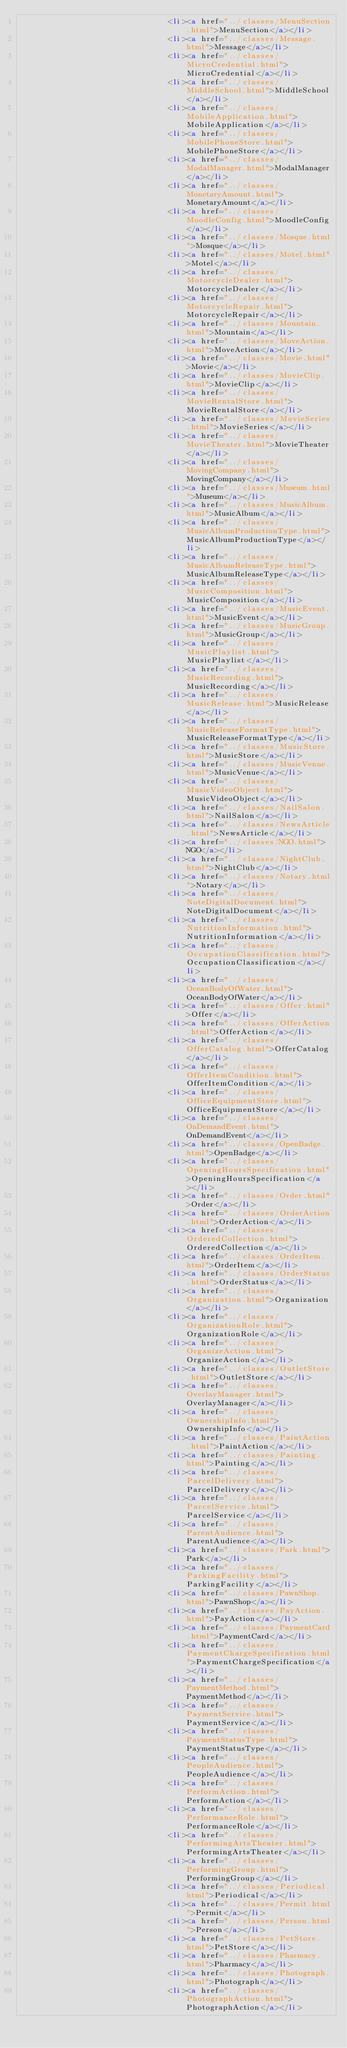<code> <loc_0><loc_0><loc_500><loc_500><_HTML_>                                <li><a href="../classes/MenuSection.html">MenuSection</a></li>
                                <li><a href="../classes/Message.html">Message</a></li>
                                <li><a href="../classes/MicroCredential.html">MicroCredential</a></li>
                                <li><a href="../classes/MiddleSchool.html">MiddleSchool</a></li>
                                <li><a href="../classes/MobileApplication.html">MobileApplication</a></li>
                                <li><a href="../classes/MobilePhoneStore.html">MobilePhoneStore</a></li>
                                <li><a href="../classes/ModalManager.html">ModalManager</a></li>
                                <li><a href="../classes/MonetaryAmount.html">MonetaryAmount</a></li>
                                <li><a href="../classes/MoodleConfig.html">MoodleConfig</a></li>
                                <li><a href="../classes/Mosque.html">Mosque</a></li>
                                <li><a href="../classes/Motel.html">Motel</a></li>
                                <li><a href="../classes/MotorcycleDealer.html">MotorcycleDealer</a></li>
                                <li><a href="../classes/MotorcycleRepair.html">MotorcycleRepair</a></li>
                                <li><a href="../classes/Mountain.html">Mountain</a></li>
                                <li><a href="../classes/MoveAction.html">MoveAction</a></li>
                                <li><a href="../classes/Movie.html">Movie</a></li>
                                <li><a href="../classes/MovieClip.html">MovieClip</a></li>
                                <li><a href="../classes/MovieRentalStore.html">MovieRentalStore</a></li>
                                <li><a href="../classes/MovieSeries.html">MovieSeries</a></li>
                                <li><a href="../classes/MovieTheater.html">MovieTheater</a></li>
                                <li><a href="../classes/MovingCompany.html">MovingCompany</a></li>
                                <li><a href="../classes/Museum.html">Museum</a></li>
                                <li><a href="../classes/MusicAlbum.html">MusicAlbum</a></li>
                                <li><a href="../classes/MusicAlbumProductionType.html">MusicAlbumProductionType</a></li>
                                <li><a href="../classes/MusicAlbumReleaseType.html">MusicAlbumReleaseType</a></li>
                                <li><a href="../classes/MusicComposition.html">MusicComposition</a></li>
                                <li><a href="../classes/MusicEvent.html">MusicEvent</a></li>
                                <li><a href="../classes/MusicGroup.html">MusicGroup</a></li>
                                <li><a href="../classes/MusicPlaylist.html">MusicPlaylist</a></li>
                                <li><a href="../classes/MusicRecording.html">MusicRecording</a></li>
                                <li><a href="../classes/MusicRelease.html">MusicRelease</a></li>
                                <li><a href="../classes/MusicReleaseFormatType.html">MusicReleaseFormatType</a></li>
                                <li><a href="../classes/MusicStore.html">MusicStore</a></li>
                                <li><a href="../classes/MusicVenue.html">MusicVenue</a></li>
                                <li><a href="../classes/MusicVideoObject.html">MusicVideoObject</a></li>
                                <li><a href="../classes/NailSalon.html">NailSalon</a></li>
                                <li><a href="../classes/NewsArticle.html">NewsArticle</a></li>
                                <li><a href="../classes/NGO.html">NGO</a></li>
                                <li><a href="../classes/NightClub.html">NightClub</a></li>
                                <li><a href="../classes/Notary.html">Notary</a></li>
                                <li><a href="../classes/NoteDigitalDocument.html">NoteDigitalDocument</a></li>
                                <li><a href="../classes/NutritionInformation.html">NutritionInformation</a></li>
                                <li><a href="../classes/OccupationClassification.html">OccupationClassification</a></li>
                                <li><a href="../classes/OceanBodyOfWater.html">OceanBodyOfWater</a></li>
                                <li><a href="../classes/Offer.html">Offer</a></li>
                                <li><a href="../classes/OfferAction.html">OfferAction</a></li>
                                <li><a href="../classes/OfferCatalog.html">OfferCatalog</a></li>
                                <li><a href="../classes/OfferItemCondition.html">OfferItemCondition</a></li>
                                <li><a href="../classes/OfficeEquipmentStore.html">OfficeEquipmentStore</a></li>
                                <li><a href="../classes/OnDemandEvent.html">OnDemandEvent</a></li>
                                <li><a href="../classes/OpenBadge.html">OpenBadge</a></li>
                                <li><a href="../classes/OpeningHoursSpecification.html">OpeningHoursSpecification</a></li>
                                <li><a href="../classes/Order.html">Order</a></li>
                                <li><a href="../classes/OrderAction.html">OrderAction</a></li>
                                <li><a href="../classes/OrderedCollection.html">OrderedCollection</a></li>
                                <li><a href="../classes/OrderItem.html">OrderItem</a></li>
                                <li><a href="../classes/OrderStatus.html">OrderStatus</a></li>
                                <li><a href="../classes/Organization.html">Organization</a></li>
                                <li><a href="../classes/OrganizationRole.html">OrganizationRole</a></li>
                                <li><a href="../classes/OrganizeAction.html">OrganizeAction</a></li>
                                <li><a href="../classes/OutletStore.html">OutletStore</a></li>
                                <li><a href="../classes/OverlayManager.html">OverlayManager</a></li>
                                <li><a href="../classes/OwnershipInfo.html">OwnershipInfo</a></li>
                                <li><a href="../classes/PaintAction.html">PaintAction</a></li>
                                <li><a href="../classes/Painting.html">Painting</a></li>
                                <li><a href="../classes/ParcelDelivery.html">ParcelDelivery</a></li>
                                <li><a href="../classes/ParcelService.html">ParcelService</a></li>
                                <li><a href="../classes/ParentAudience.html">ParentAudience</a></li>
                                <li><a href="../classes/Park.html">Park</a></li>
                                <li><a href="../classes/ParkingFacility.html">ParkingFacility</a></li>
                                <li><a href="../classes/PawnShop.html">PawnShop</a></li>
                                <li><a href="../classes/PayAction.html">PayAction</a></li>
                                <li><a href="../classes/PaymentCard.html">PaymentCard</a></li>
                                <li><a href="../classes/PaymentChargeSpecification.html">PaymentChargeSpecification</a></li>
                                <li><a href="../classes/PaymentMethod.html">PaymentMethod</a></li>
                                <li><a href="../classes/PaymentService.html">PaymentService</a></li>
                                <li><a href="../classes/PaymentStatusType.html">PaymentStatusType</a></li>
                                <li><a href="../classes/PeopleAudience.html">PeopleAudience</a></li>
                                <li><a href="../classes/PerformAction.html">PerformAction</a></li>
                                <li><a href="../classes/PerformanceRole.html">PerformanceRole</a></li>
                                <li><a href="../classes/PerformingArtsTheater.html">PerformingArtsTheater</a></li>
                                <li><a href="../classes/PerformingGroup.html">PerformingGroup</a></li>
                                <li><a href="../classes/Periodical.html">Periodical</a></li>
                                <li><a href="../classes/Permit.html">Permit</a></li>
                                <li><a href="../classes/Person.html">Person</a></li>
                                <li><a href="../classes/PetStore.html">PetStore</a></li>
                                <li><a href="../classes/Pharmacy.html">Pharmacy</a></li>
                                <li><a href="../classes/Photograph.html">Photograph</a></li>
                                <li><a href="../classes/PhotographAction.html">PhotographAction</a></li></code> 